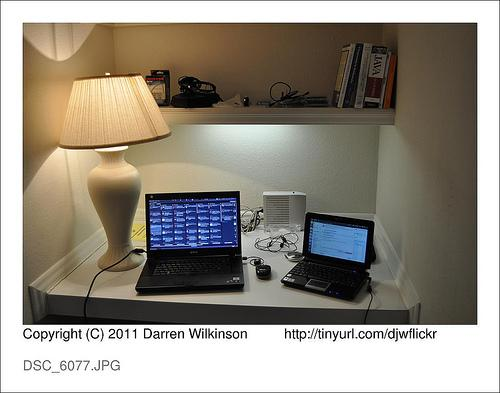How would you describe the overall sentiment or mood of the image? The image has a calm and productive atmosphere, representing a well-organized workspace for study or work. Count and identify the different types of cables or cords visible in the image. There are three types of cords: a long black cord for one of the laptops, chords going into the modem, and a chord hanging off the smaller laptop. Write a sentence describing the general state of the workspace shown in the image. The image shows a clean and organized workspace with two laptops, a lamp, and a neatly arranged shelf with books. What objects can be found on the top shelf, and how are they arranged? There are books on the top shelf, stacked neatly side by side. In the context of the image, identify any sources of light and describe their appearances. There is a lit white lamp with a generic white lamp shade on the desk and bright light shades against the wall. Describe any items related to the laptops on the desk, including their positions and appearances. There is a laptop mouse near the laptops, a long black cord for the larger laptop, and chords going into the modem near the laptops. Are there any objects related to audio or sound in the image? If yes, describe them and their locations. Yes, there is a pair of headphones bundled on the shelf next to the books. How many laptops are there in the image, and what are their differences, if any? There are two laptops: a larger laptop with a visible screen and a smaller netbook with a tiny screen and hanging chord. Can you spot any reading materials in the image? If yes, provide a brief description. Yes, there is a stack of books on a shelf and a book about Java among them. What kind of electronic devices are visible in the image? There are two laptops, a laptop mouse, a pair of headphones, and a modem in the image. Describe the interactions among objects in the image. The laptops and netbook are connected to cords; the study lamp provides light for the workspace; the mouse interacts with one of the laptops. Ground the expression "headphones bundled on the shelf." X:170 Y:67 Width:50 Height:50 Analyze the sentiment evoked by the image. The image evokes a feeling of productivity and organization. Does the pile of clothes beside the laptop seem messy? No, it's not mentioned in the image. What type of books are on the top shelf? There is a book about Java and a stack of generic books. How many lamps are present in the image? One study lamp. Identify the attributes of the study lamp. Lit, white, and with a generic lampshade. Which object has the smallest height in the image? Bright light shade against the wall at X:173 Y:271 with zero height. Is the green book about Python on the top shelf? While there is a mention of a book about Java, no book about Python and no green book have been mentioned. Introducing a green book about Python as an existing object in the image is misleading. Read the text from the book visible in the image. Java Which object has a position X:330 Y:42? A stack of books. Detect any anomalies in the image. No significant anomalies detected in the image. Classify the semantic segments in the image. Laptops, netbooks, study lamps, laptop screens, cords, book stacks, desks, and light reflections. How many laptops does the image show? It shows two laptops: one larger and one smaller. Identify the objects on the top shelf. A stack of books, a book about Java, a pair of headphones, and some loose cords. Which object has a long cord hanging from it? The black laptop at position X:62 Y:256 has the long cord hanging. Can you see the five study lamps placed on the desk? There are only two study lamps described in the image, mentioning five lamps is misleading as it contradicts the given information. What is the smallest screen for a laptop? X:306 Y:221 Width:60 Height:60 Mention the color of the laptops on the table. Black. Describe the lamp shade on the desk. The lamp shade is white and has a position of X:59 Y:62 with a width of 112 and height of 112. Which object has the largest width? A very clean white desk with a width of 358. Describe the main objects present on the very clean white desk. Two laptops, a tiny black netbook, a black laptop, a study lamp, a pile of loose cords, a laptop mouse, and a long black cord are on the desk. 